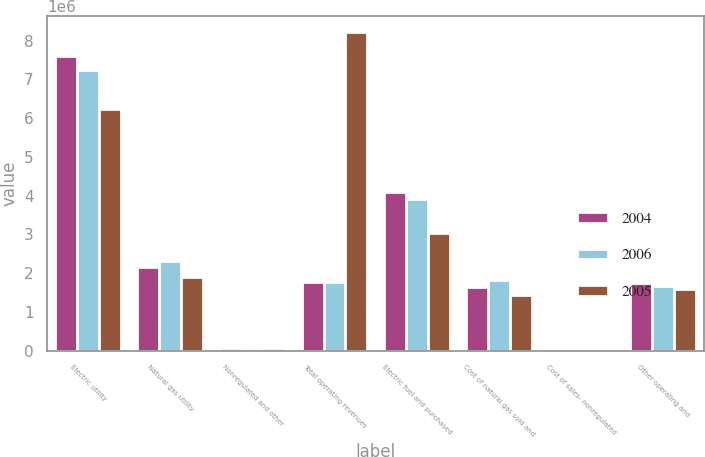<chart> <loc_0><loc_0><loc_500><loc_500><stacked_bar_chart><ecel><fcel>Electric utility<fcel>Natural gas utility<fcel>Nonregulated and other<fcel>Total operating revenues<fcel>Electric fuel and purchased<fcel>Cost of natural gas sold and<fcel>Cost of sales- nonregulated<fcel>Other operating and<nl><fcel>2004<fcel>7.60802e+06<fcel>2.156e+06<fcel>76287<fcel>1.78329e+06<fcel>4.10306e+06<fcel>1.64472e+06<fcel>24388<fcel>1.74346e+06<nl><fcel>2006<fcel>7.24364e+06<fcel>2.30738e+06<fcel>74455<fcel>1.78329e+06<fcel>3.92216e+06<fcel>1.82312e+06<fcel>24676<fcel>1.67917e+06<nl><fcel>2005<fcel>6.22524e+06<fcel>1.91551e+06<fcel>74802<fcel>8.21556e+06<fcel>3.04076e+06<fcel>1.44577e+06<fcel>28757<fcel>1.59172e+06<nl></chart> 